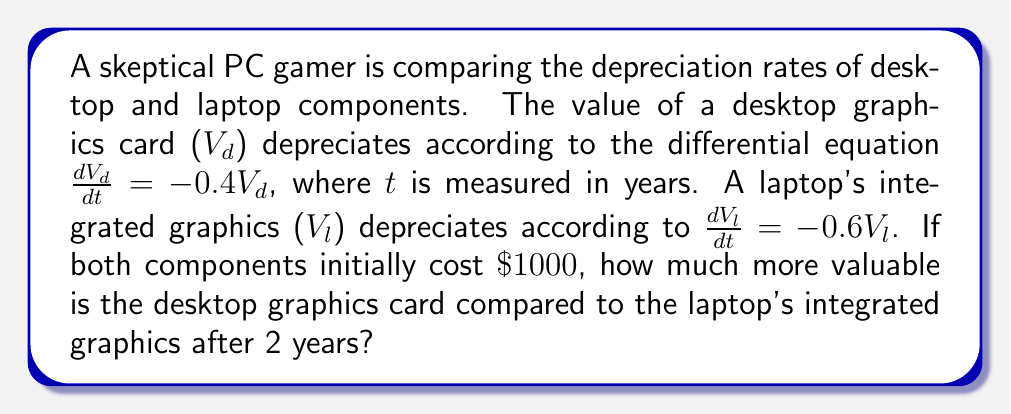Show me your answer to this math problem. To solve this problem, we need to use the general solution for first-order linear differential equations of the form $\frac{dV}{dt} = kV$, which is $V(t) = V_0e^{kt}$, where $V_0$ is the initial value.

For the desktop graphics card:
1. The equation is $\frac{dV_d}{dt} = -0.4V_d$
2. The general solution is $V_d(t) = V_{d0}e^{-0.4t}$
3. Given $V_{d0} = 1000$, we have $V_d(t) = 1000e^{-0.4t}$
4. After 2 years, $V_d(2) = 1000e^{-0.4(2)} = 1000e^{-0.8} \approx 449.33$

For the laptop's integrated graphics:
1. The equation is $\frac{dV_l}{dt} = -0.6V_l$
2. The general solution is $V_l(t) = V_{l0}e^{-0.6t}$
3. Given $V_{l0} = 1000$, we have $V_l(t) = 1000e^{-0.6t}$
4. After 2 years, $V_l(2) = 1000e^{-0.6(2)} = 1000e^{-1.2} \approx 301.19$

The difference in value after 2 years is:
$V_d(2) - V_l(2) = 449.33 - 301.19 = 148.14$

Therefore, the desktop graphics card is approximately $\$148.14$ more valuable than the laptop's integrated graphics after 2 years.
Answer: $\$148.14$ 